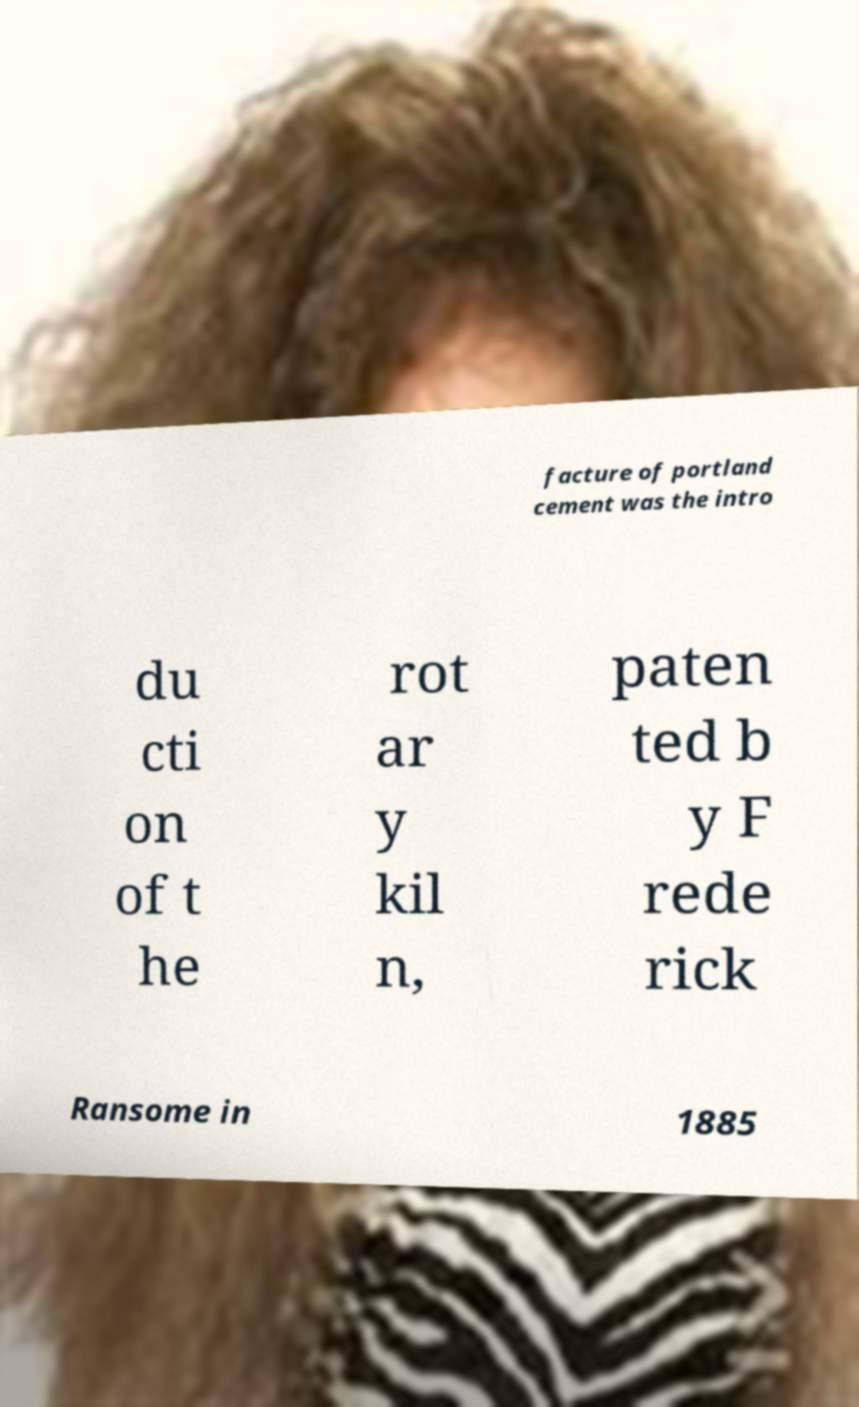There's text embedded in this image that I need extracted. Can you transcribe it verbatim? facture of portland cement was the intro du cti on of t he rot ar y kil n, paten ted b y F rede rick Ransome in 1885 